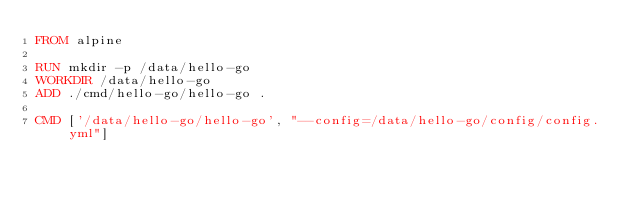<code> <loc_0><loc_0><loc_500><loc_500><_Dockerfile_>FROM alpine

RUN mkdir -p /data/hello-go
WORKDIR /data/hello-go
ADD ./cmd/hello-go/hello-go .

CMD ['/data/hello-go/hello-go', "--config=/data/hello-go/config/config.yml"]
</code> 